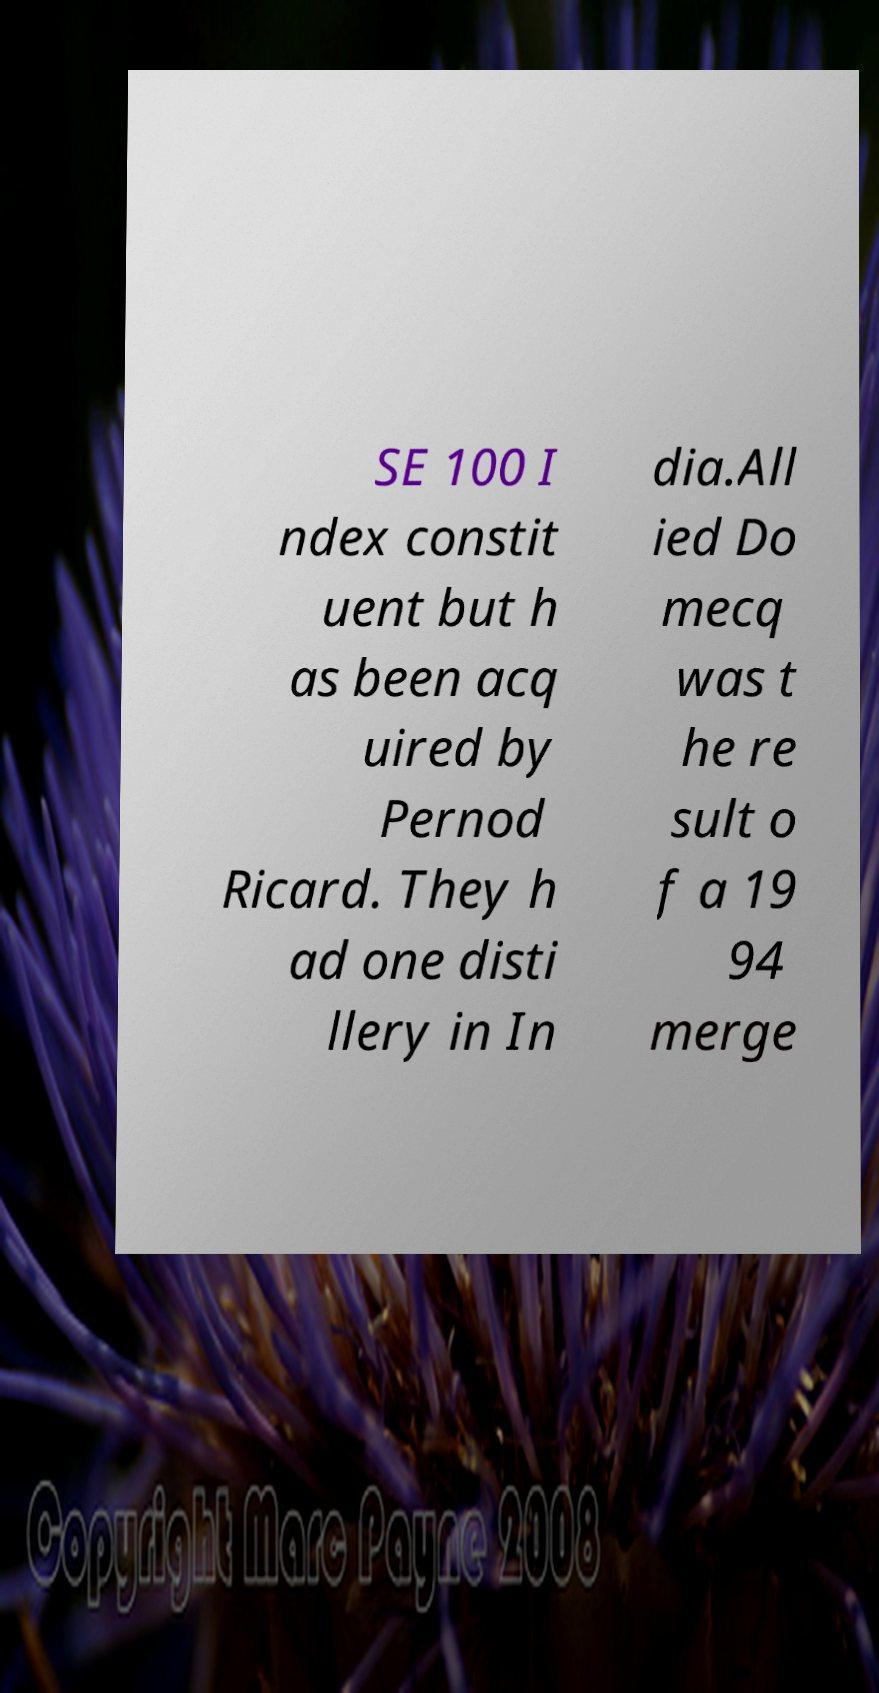Could you extract and type out the text from this image? SE 100 I ndex constit uent but h as been acq uired by Pernod Ricard. They h ad one disti llery in In dia.All ied Do mecq was t he re sult o f a 19 94 merge 